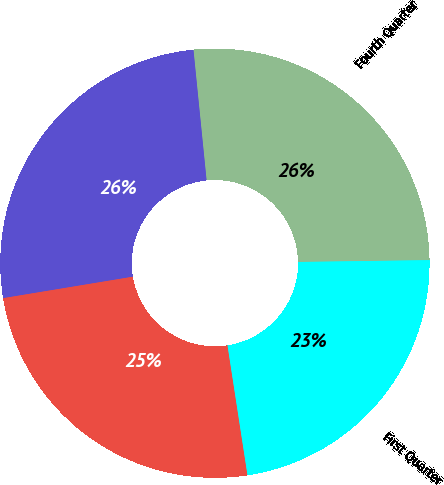Convert chart. <chart><loc_0><loc_0><loc_500><loc_500><pie_chart><fcel>Fourth Quarter<fcel>Third Quarter<fcel>Second Quarter<fcel>First Quarter<nl><fcel>26.37%<fcel>26.01%<fcel>24.82%<fcel>22.79%<nl></chart> 